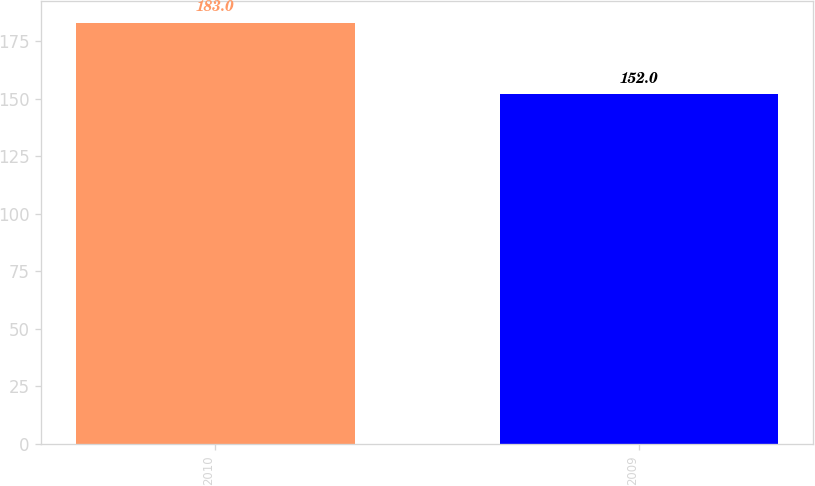Convert chart to OTSL. <chart><loc_0><loc_0><loc_500><loc_500><bar_chart><fcel>2010<fcel>2009<nl><fcel>183<fcel>152<nl></chart> 